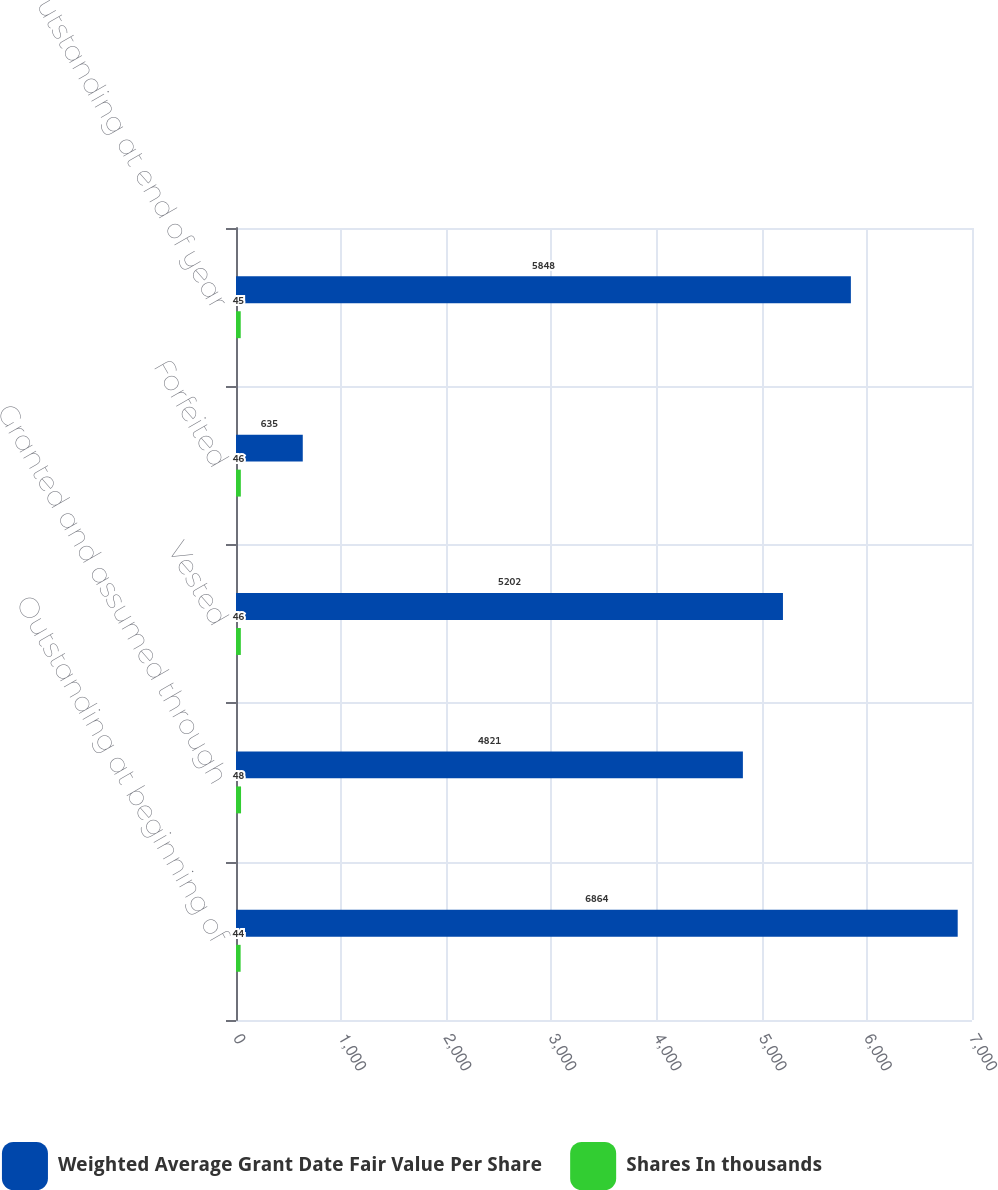Convert chart. <chart><loc_0><loc_0><loc_500><loc_500><stacked_bar_chart><ecel><fcel>Outstanding at beginning of<fcel>Granted and assumed through<fcel>Vested<fcel>Forfeited<fcel>Outstanding at end of year<nl><fcel>Weighted Average Grant Date Fair Value Per Share<fcel>6864<fcel>4821<fcel>5202<fcel>635<fcel>5848<nl><fcel>Shares In thousands<fcel>44<fcel>48<fcel>46<fcel>46<fcel>45<nl></chart> 